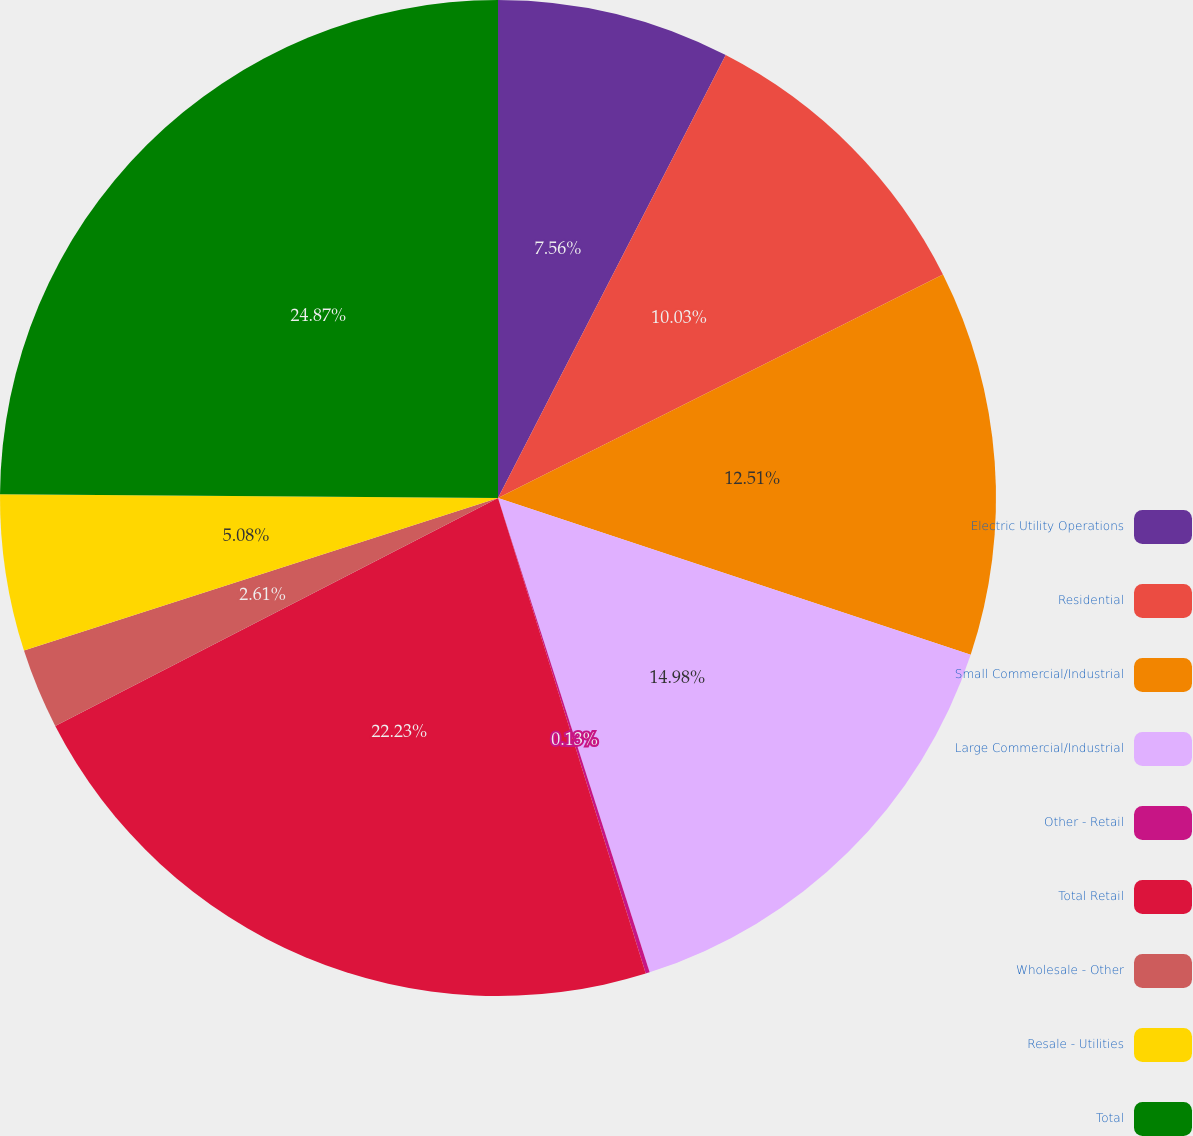Convert chart. <chart><loc_0><loc_0><loc_500><loc_500><pie_chart><fcel>Electric Utility Operations<fcel>Residential<fcel>Small Commercial/Industrial<fcel>Large Commercial/Industrial<fcel>Other - Retail<fcel>Total Retail<fcel>Wholesale - Other<fcel>Resale - Utilities<fcel>Total<nl><fcel>7.56%<fcel>10.03%<fcel>12.51%<fcel>14.98%<fcel>0.13%<fcel>22.23%<fcel>2.61%<fcel>5.08%<fcel>24.88%<nl></chart> 